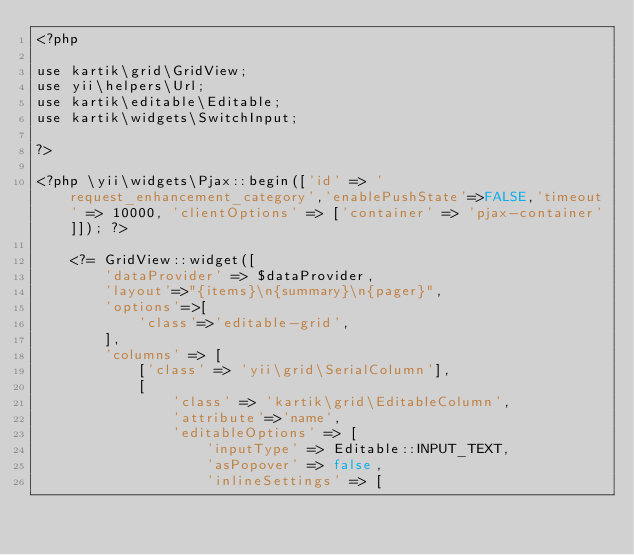Convert code to text. <code><loc_0><loc_0><loc_500><loc_500><_PHP_><?php

use kartik\grid\GridView;
use yii\helpers\Url;
use kartik\editable\Editable;
use kartik\widgets\SwitchInput;

?>

<?php \yii\widgets\Pjax::begin(['id' => 'request_enhancement_category','enablePushState'=>FALSE,'timeout' => 10000, 'clientOptions' => ['container' => 'pjax-container']]); ?>

    <?= GridView::widget([
        'dataProvider' => $dataProvider,
        'layout'=>"{items}\n{summary}\n{pager}",
        'options'=>[
            'class'=>'editable-grid',
        ],
        'columns' => [
            ['class' => 'yii\grid\SerialColumn'],
            [
                'class' => 'kartik\grid\EditableColumn',
                'attribute'=>'name', 
                'editableOptions' => [
                    'inputType' => Editable::INPUT_TEXT,
                    'asPopover' => false,
                    'inlineSettings' => [</code> 